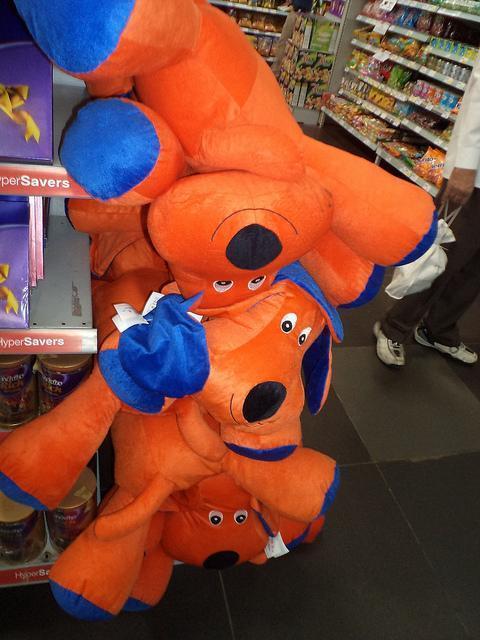How many dogs are there?
Give a very brief answer. 2. 